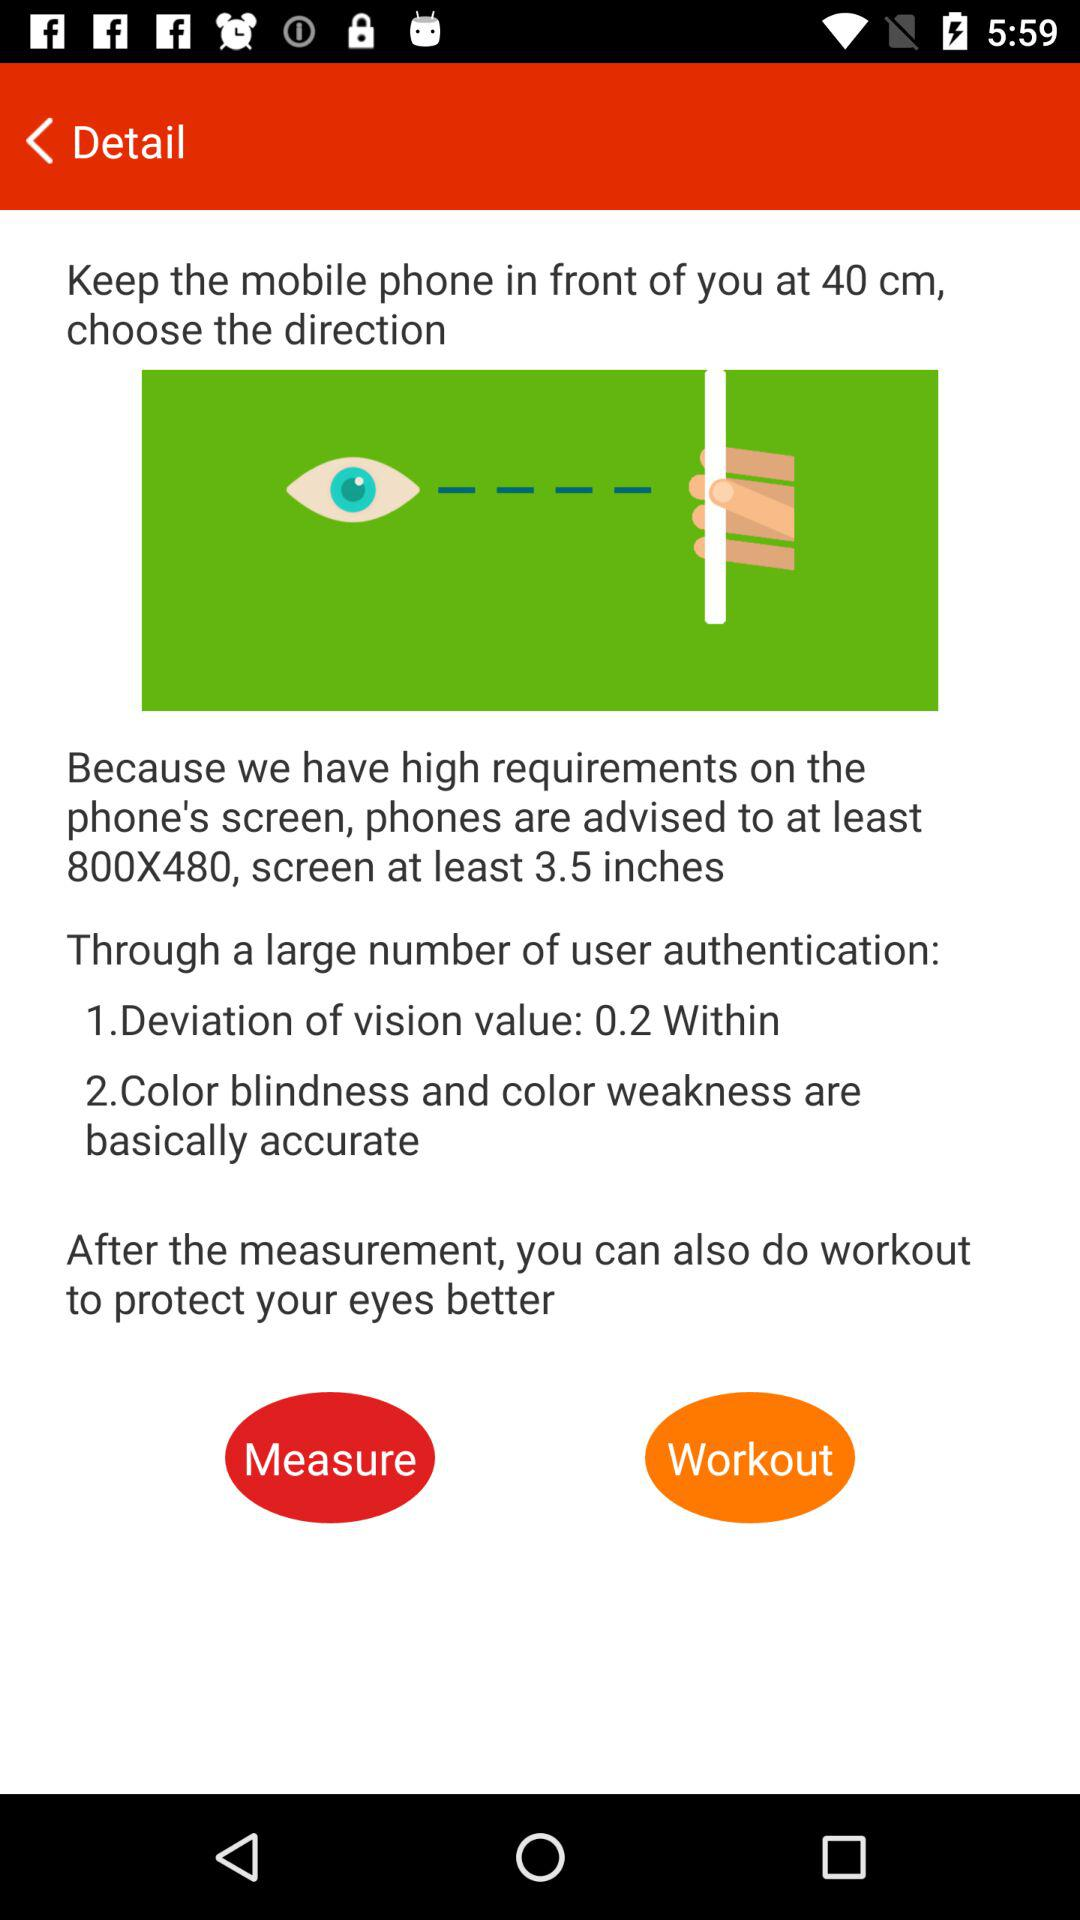How many inches is the screen at least?
Answer the question using a single word or phrase. 3.5 